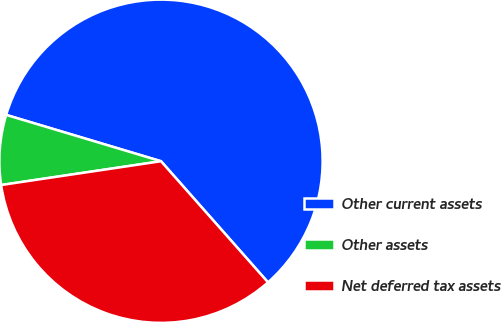<chart> <loc_0><loc_0><loc_500><loc_500><pie_chart><fcel>Other current assets<fcel>Other assets<fcel>Net deferred tax assets<nl><fcel>58.85%<fcel>6.98%<fcel>34.16%<nl></chart> 